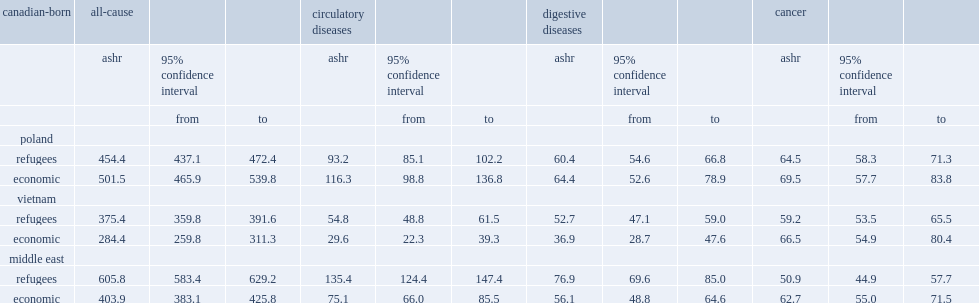For vietnam and the middle east,who had higher all-cause ashrs ,refugees or economic class immigrants from the same areas? Refugees. What was the number of the ashrs of polish refugees? 454.4. 